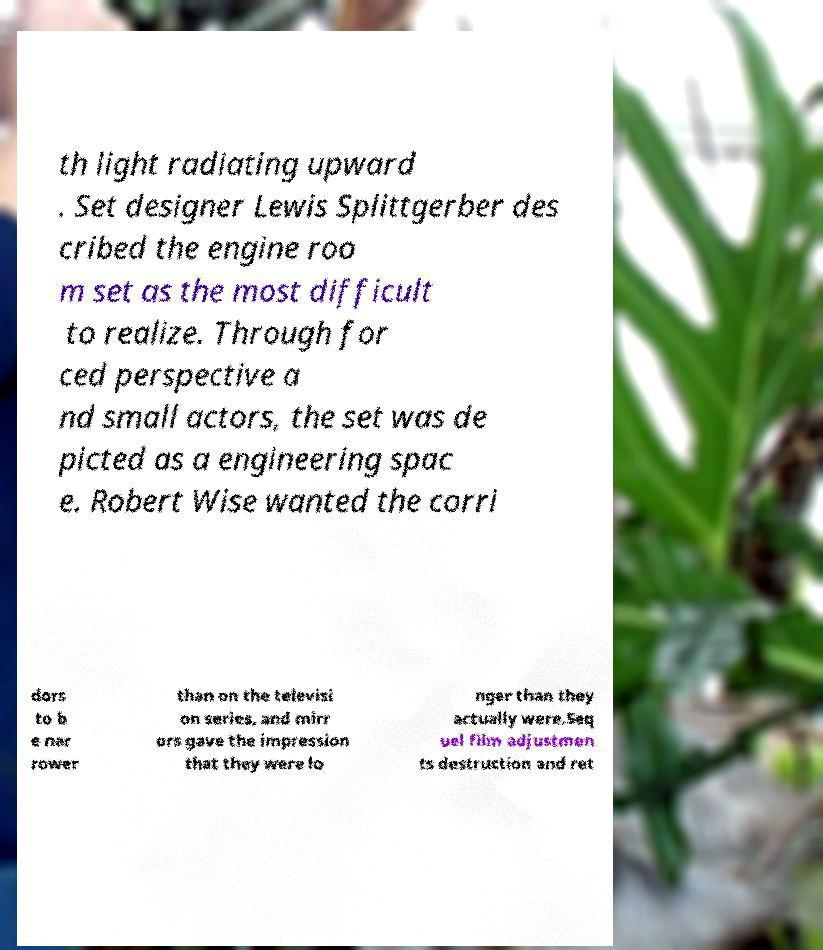I need the written content from this picture converted into text. Can you do that? th light radiating upward . Set designer Lewis Splittgerber des cribed the engine roo m set as the most difficult to realize. Through for ced perspective a nd small actors, the set was de picted as a engineering spac e. Robert Wise wanted the corri dors to b e nar rower than on the televisi on series, and mirr ors gave the impression that they were lo nger than they actually were.Seq uel film adjustmen ts destruction and ret 